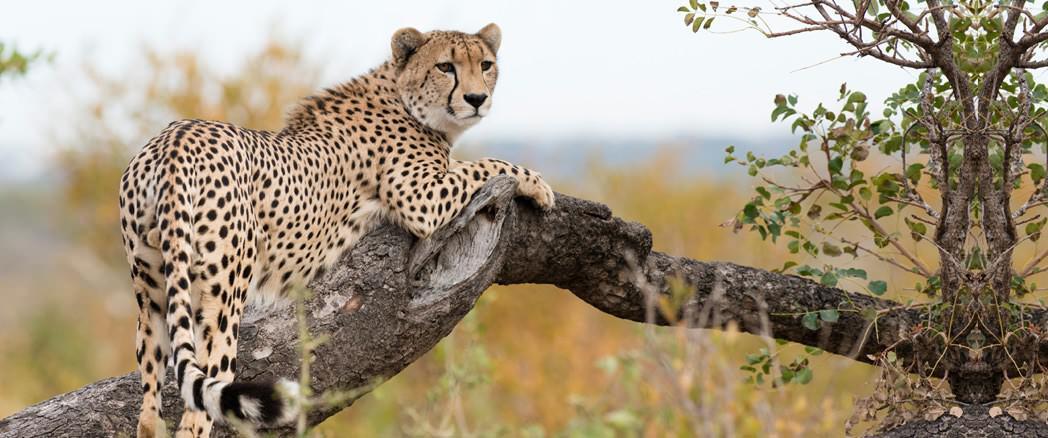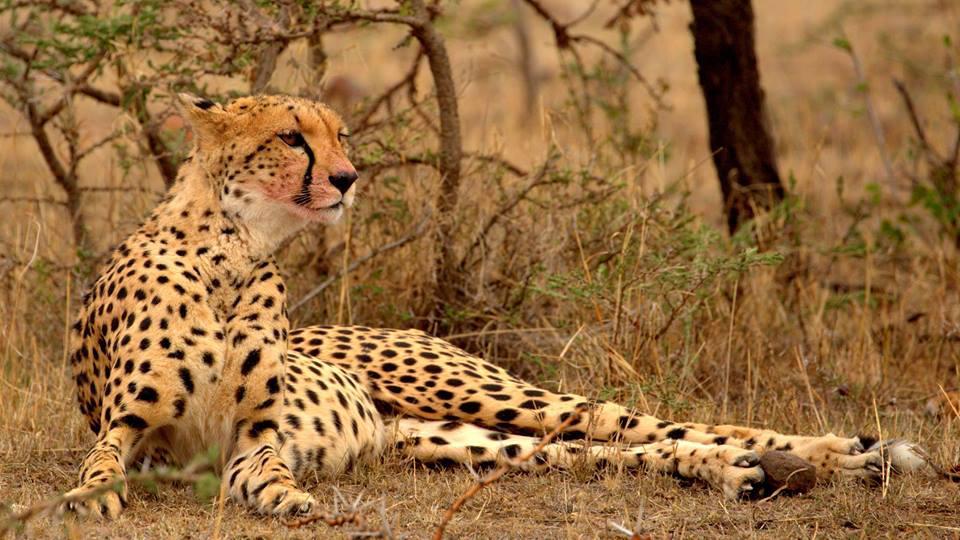The first image is the image on the left, the second image is the image on the right. Evaluate the accuracy of this statement regarding the images: "Each image includes an adult cheetah reclining on the ground with its head raised.". Is it true? Answer yes or no. No. 